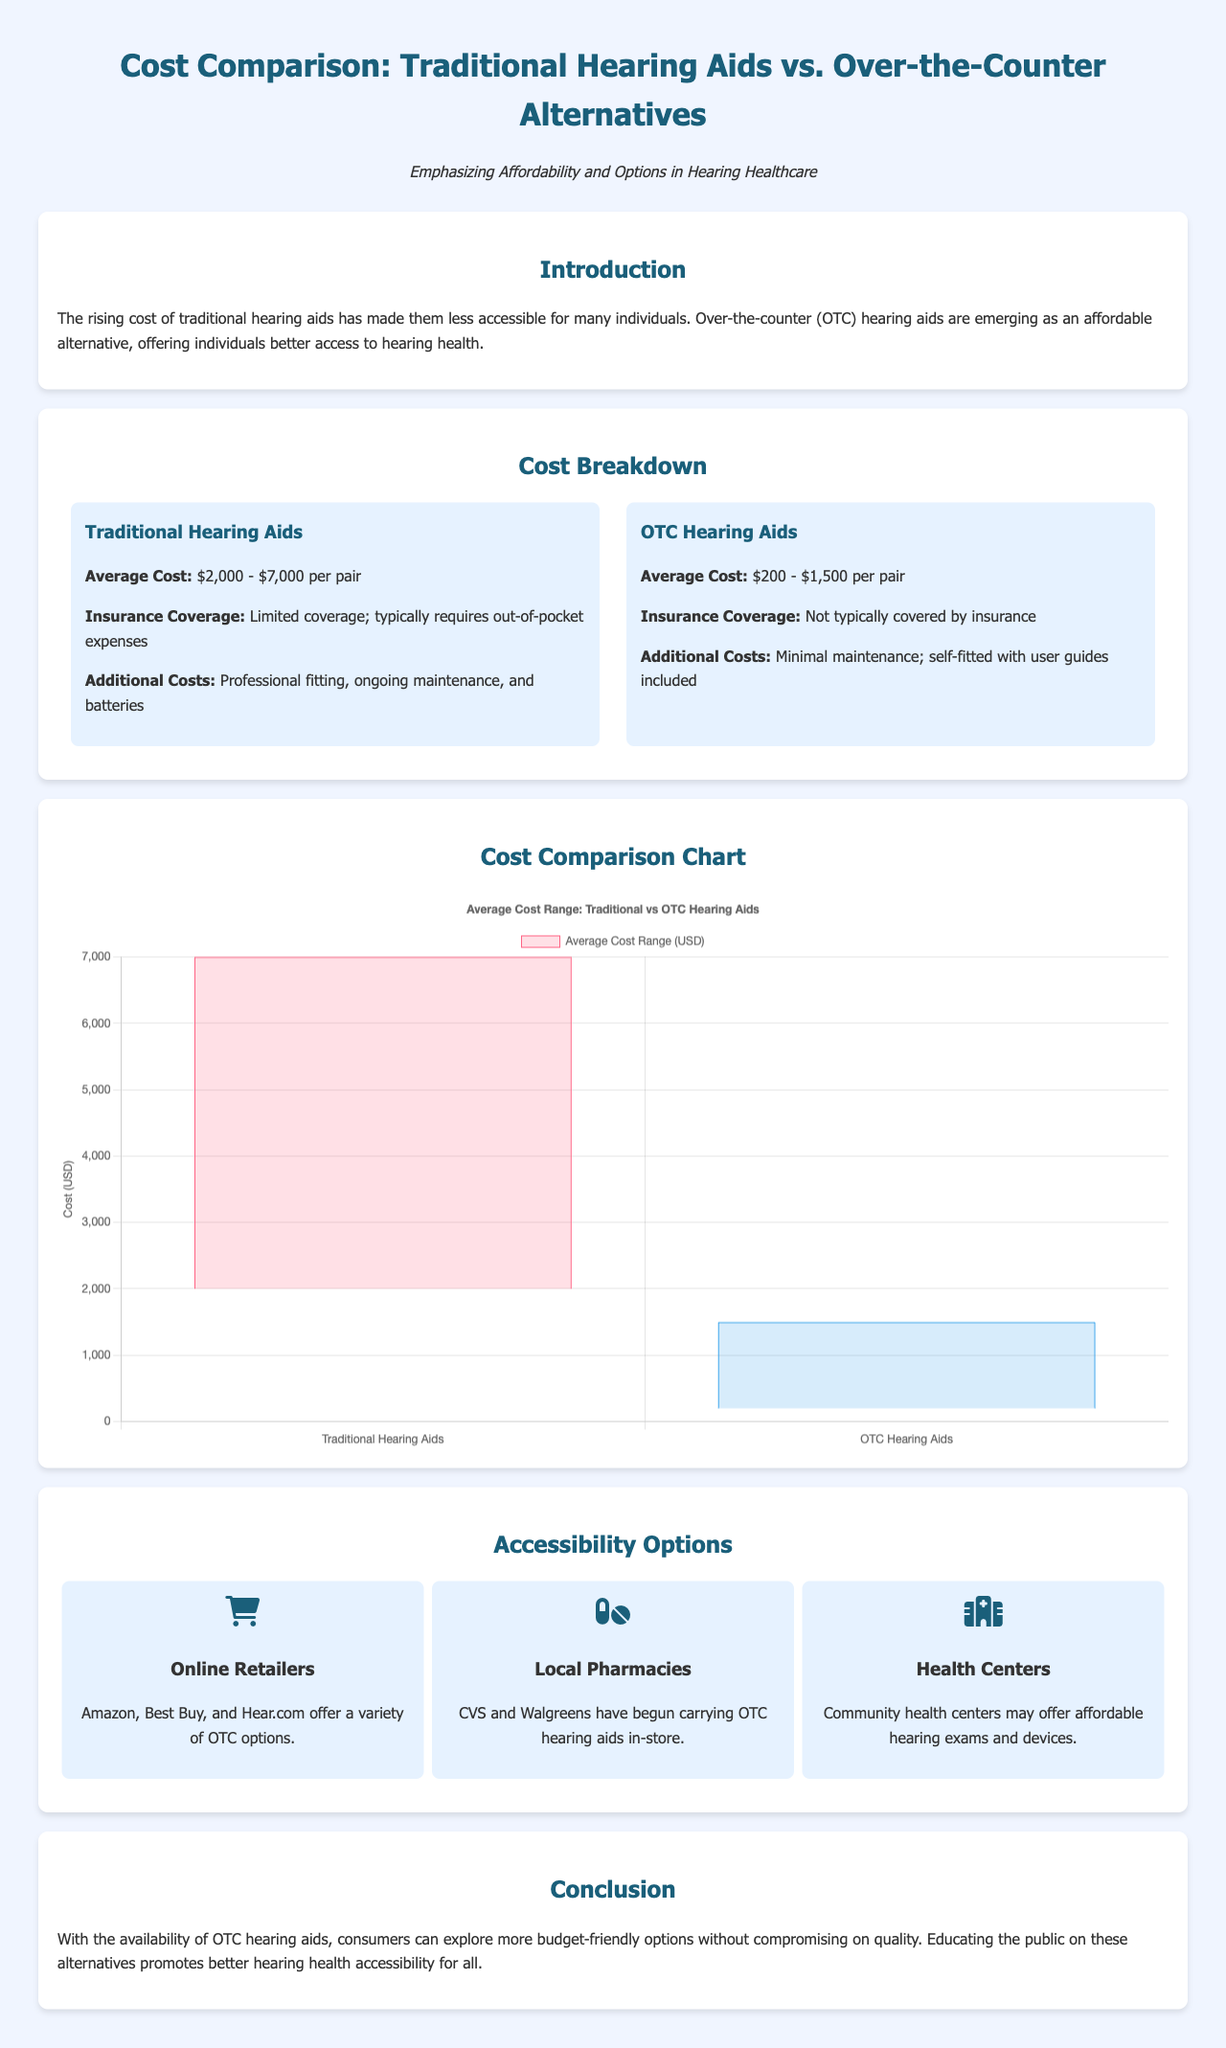What is the average cost range for traditional hearing aids? The average cost range for traditional hearing aids is explicitly mentioned in the cost breakdown section, which states it is between $2,000 and $7,000 per pair.
Answer: $2,000 - $7,000 What is the average cost range for OTC hearing aids? Similar to traditional hearing aids, the average cost range for OTC hearing aids is provided and noted as between $200 and $1,500 per pair in the cost breakdown section.
Answer: $200 - $1,500 Are traditional hearing aids typically covered by insurance? The document specifies that traditional hearing aids have limited insurance coverage, which implies that they generally require out-of-pocket expenses.
Answer: Limited coverage What is the main benefit of OTC hearing aids mentioned in the document? The introduction mentions that OTC hearing aids are emerging as affordable alternatives that offer better access to hearing health, emphasizing their affordability.
Answer: Affordability Which retailers offer OTC hearing aids? The document lists Amazon, Best Buy, and Hear.com as online retailers providing a variety of OTC options.
Answer: Amazon, Best Buy, Hear.com What do the additional costs of traditional hearing aids include? The additional costs associated with traditional hearing aids include professional fitting, ongoing maintenance, and batteries.
Answer: Fitting, maintenance, batteries What is one accessibility option for purchasing hearing aids mentioned in the document? The document references local pharmacies, such as CVS and Walgreens, which have begun carrying OTC hearing aids in-store as an accessibility option.
Answer: Local pharmacies What type of chart is used in the document to present the cost comparison? The document states that a bar chart is used to visually present the average cost range for traditional versus OTC hearing aids.
Answer: Bar chart 